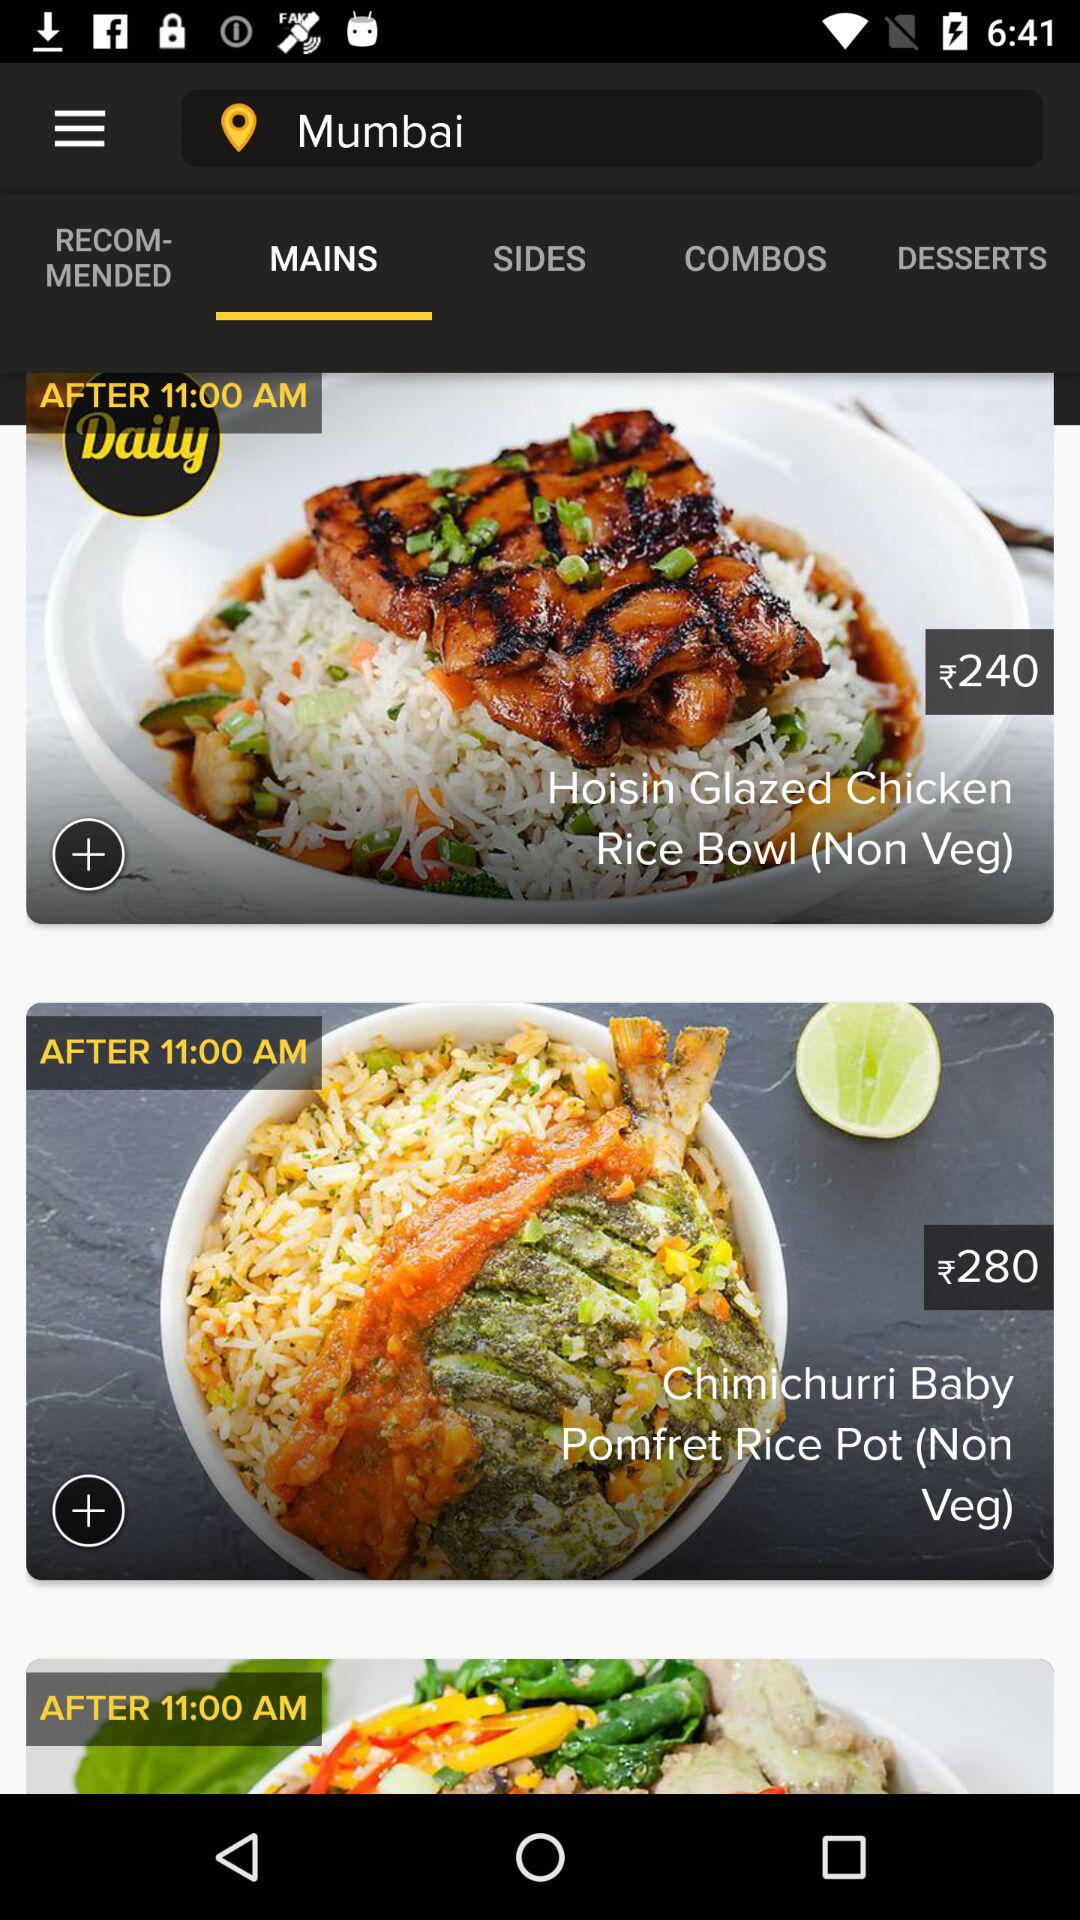What is the price of hoisin glazed chicken rice? The price of hoisin glazed chicken rice is ₹240. 